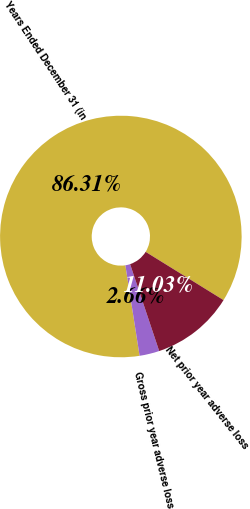Convert chart to OTSL. <chart><loc_0><loc_0><loc_500><loc_500><pie_chart><fcel>Years Ended December 31 (in<fcel>Gross prior year adverse loss<fcel>Net prior year adverse loss<nl><fcel>86.31%<fcel>2.66%<fcel>11.03%<nl></chart> 